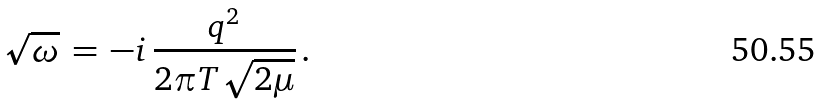<formula> <loc_0><loc_0><loc_500><loc_500>\sqrt { \omega } \, = \, - i \, \frac { q ^ { 2 } } { 2 \pi T \sqrt { 2 \mu } } \, .</formula> 